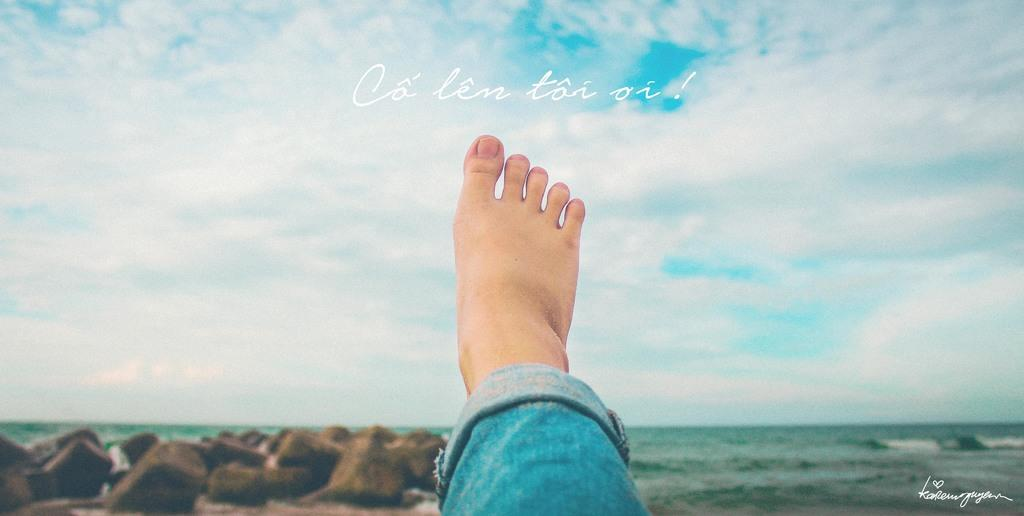What part of a person's body can be seen in the image? There is a person's leg visible in the image. What type of clothing is the person wearing? The person is wearing jeans. What type of natural elements are present in the image? There are rocks and water visible in the image. What can be seen in the background of the image? The sky is visible in the background of the image. Can you tell me how many volcanoes are visible in the image? There are no volcanoes present in the image; it only shows a person's leg, jeans, rocks, water, and the sky. What type of toy is the cub playing with in the image? There is no cub or toy present in the image. 